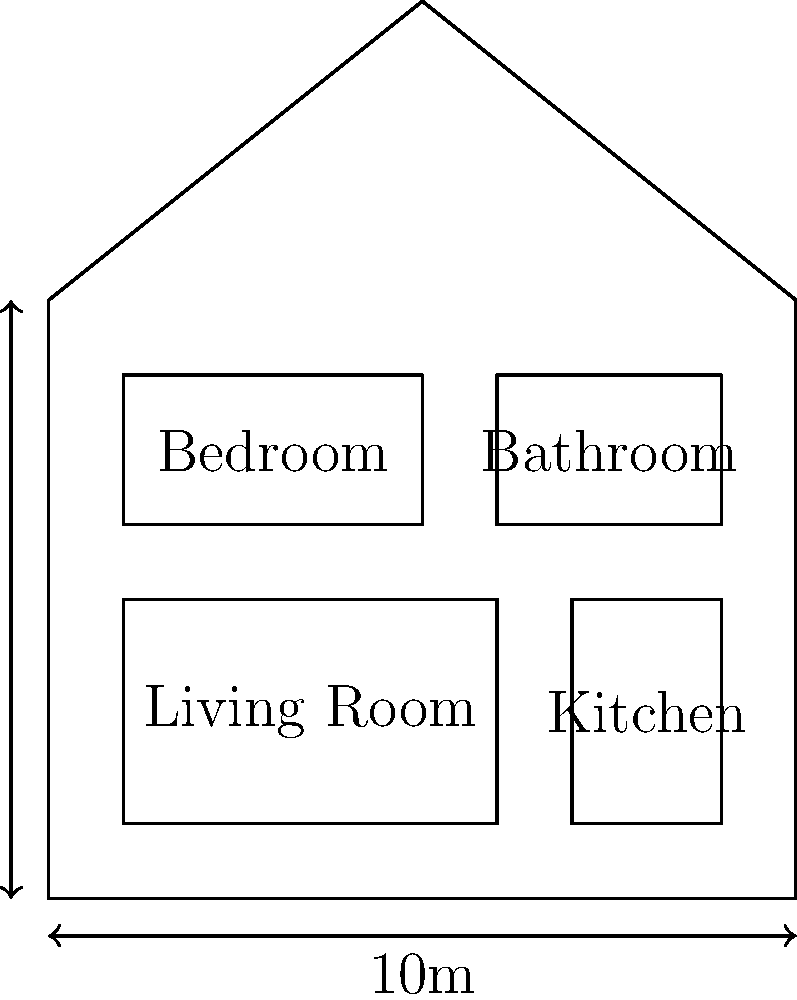In the typical home layout of your story's setting, what is the ratio of the living room area to the total floor area of the house, expressed as a percentage? To solve this problem, we need to follow these steps:

1. Calculate the total floor area of the house:
   The house is 10m wide and 8m deep.
   Total area = $10m \times 8m = 80m^2$

2. Calculate the area of the living room:
   The living room occupies 5/10 of the width and 3/8 of the depth.
   Living room area = $(5/10 \times 10m) \times (3/8 \times 8m) = 5m \times 3m = 15m^2$

3. Calculate the ratio of living room area to total floor area:
   Ratio = $\frac{\text{Living room area}}{\text{Total floor area}} = \frac{15m^2}{80m^2} = \frac{3}{16} = 0.1875$

4. Convert the ratio to a percentage:
   Percentage = $0.1875 \times 100\% = 18.75\%$

Therefore, the living room occupies 18.75% of the total floor area of the house.
Answer: 18.75% 